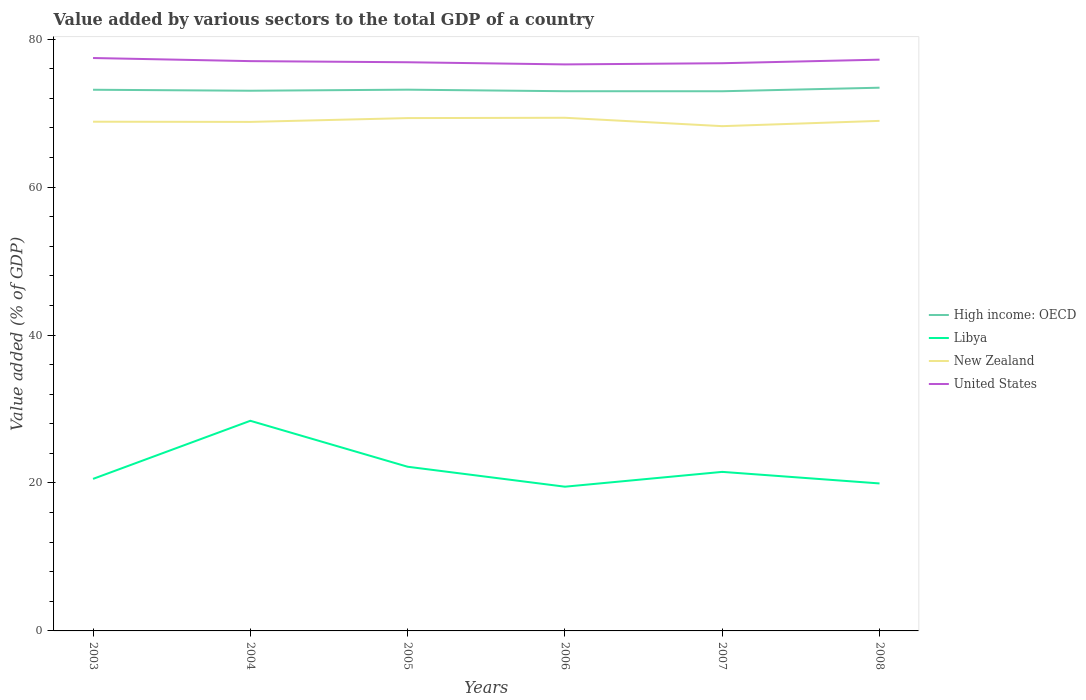How many different coloured lines are there?
Provide a short and direct response. 4. Does the line corresponding to Libya intersect with the line corresponding to United States?
Give a very brief answer. No. Is the number of lines equal to the number of legend labels?
Provide a succinct answer. Yes. Across all years, what is the maximum value added by various sectors to the total GDP in High income: OECD?
Make the answer very short. 72.95. In which year was the value added by various sectors to the total GDP in United States maximum?
Your answer should be very brief. 2006. What is the total value added by various sectors to the total GDP in High income: OECD in the graph?
Offer a very short reply. 0.21. What is the difference between the highest and the second highest value added by various sectors to the total GDP in High income: OECD?
Your answer should be very brief. 0.48. What is the difference between the highest and the lowest value added by various sectors to the total GDP in Libya?
Make the answer very short. 2. Is the value added by various sectors to the total GDP in Libya strictly greater than the value added by various sectors to the total GDP in United States over the years?
Give a very brief answer. Yes. Are the values on the major ticks of Y-axis written in scientific E-notation?
Provide a short and direct response. No. Does the graph contain grids?
Make the answer very short. No. Where does the legend appear in the graph?
Make the answer very short. Center right. How are the legend labels stacked?
Keep it short and to the point. Vertical. What is the title of the graph?
Give a very brief answer. Value added by various sectors to the total GDP of a country. What is the label or title of the Y-axis?
Ensure brevity in your answer.  Value added (% of GDP). What is the Value added (% of GDP) in High income: OECD in 2003?
Make the answer very short. 73.16. What is the Value added (% of GDP) in Libya in 2003?
Offer a terse response. 20.55. What is the Value added (% of GDP) of New Zealand in 2003?
Offer a terse response. 68.83. What is the Value added (% of GDP) in United States in 2003?
Ensure brevity in your answer.  77.45. What is the Value added (% of GDP) of High income: OECD in 2004?
Keep it short and to the point. 73.02. What is the Value added (% of GDP) in Libya in 2004?
Offer a terse response. 28.41. What is the Value added (% of GDP) in New Zealand in 2004?
Offer a terse response. 68.81. What is the Value added (% of GDP) of United States in 2004?
Ensure brevity in your answer.  77.02. What is the Value added (% of GDP) in High income: OECD in 2005?
Offer a very short reply. 73.16. What is the Value added (% of GDP) in Libya in 2005?
Offer a terse response. 22.19. What is the Value added (% of GDP) of New Zealand in 2005?
Offer a very short reply. 69.32. What is the Value added (% of GDP) in United States in 2005?
Make the answer very short. 76.87. What is the Value added (% of GDP) of High income: OECD in 2006?
Your response must be concise. 72.96. What is the Value added (% of GDP) in Libya in 2006?
Your answer should be very brief. 19.5. What is the Value added (% of GDP) of New Zealand in 2006?
Ensure brevity in your answer.  69.37. What is the Value added (% of GDP) in United States in 2006?
Offer a very short reply. 76.58. What is the Value added (% of GDP) in High income: OECD in 2007?
Make the answer very short. 72.95. What is the Value added (% of GDP) of Libya in 2007?
Your answer should be very brief. 21.5. What is the Value added (% of GDP) in New Zealand in 2007?
Your answer should be compact. 68.23. What is the Value added (% of GDP) of United States in 2007?
Give a very brief answer. 76.74. What is the Value added (% of GDP) in High income: OECD in 2008?
Your answer should be compact. 73.43. What is the Value added (% of GDP) in Libya in 2008?
Offer a very short reply. 19.94. What is the Value added (% of GDP) of New Zealand in 2008?
Keep it short and to the point. 68.95. What is the Value added (% of GDP) in United States in 2008?
Give a very brief answer. 77.22. Across all years, what is the maximum Value added (% of GDP) in High income: OECD?
Offer a terse response. 73.43. Across all years, what is the maximum Value added (% of GDP) in Libya?
Keep it short and to the point. 28.41. Across all years, what is the maximum Value added (% of GDP) of New Zealand?
Give a very brief answer. 69.37. Across all years, what is the maximum Value added (% of GDP) of United States?
Offer a terse response. 77.45. Across all years, what is the minimum Value added (% of GDP) in High income: OECD?
Provide a succinct answer. 72.95. Across all years, what is the minimum Value added (% of GDP) in Libya?
Your response must be concise. 19.5. Across all years, what is the minimum Value added (% of GDP) of New Zealand?
Ensure brevity in your answer.  68.23. Across all years, what is the minimum Value added (% of GDP) of United States?
Your answer should be very brief. 76.58. What is the total Value added (% of GDP) of High income: OECD in the graph?
Provide a short and direct response. 438.68. What is the total Value added (% of GDP) in Libya in the graph?
Offer a very short reply. 132.08. What is the total Value added (% of GDP) of New Zealand in the graph?
Provide a succinct answer. 413.51. What is the total Value added (% of GDP) in United States in the graph?
Your answer should be very brief. 461.89. What is the difference between the Value added (% of GDP) in High income: OECD in 2003 and that in 2004?
Offer a very short reply. 0.13. What is the difference between the Value added (% of GDP) of Libya in 2003 and that in 2004?
Offer a very short reply. -7.85. What is the difference between the Value added (% of GDP) of New Zealand in 2003 and that in 2004?
Your answer should be compact. 0.03. What is the difference between the Value added (% of GDP) in United States in 2003 and that in 2004?
Your response must be concise. 0.42. What is the difference between the Value added (% of GDP) of High income: OECD in 2003 and that in 2005?
Ensure brevity in your answer.  -0.01. What is the difference between the Value added (% of GDP) of Libya in 2003 and that in 2005?
Provide a short and direct response. -1.64. What is the difference between the Value added (% of GDP) in New Zealand in 2003 and that in 2005?
Give a very brief answer. -0.49. What is the difference between the Value added (% of GDP) in United States in 2003 and that in 2005?
Your response must be concise. 0.57. What is the difference between the Value added (% of GDP) in High income: OECD in 2003 and that in 2006?
Your answer should be compact. 0.2. What is the difference between the Value added (% of GDP) in Libya in 2003 and that in 2006?
Your answer should be compact. 1.06. What is the difference between the Value added (% of GDP) in New Zealand in 2003 and that in 2006?
Your answer should be very brief. -0.53. What is the difference between the Value added (% of GDP) in United States in 2003 and that in 2006?
Offer a very short reply. 0.86. What is the difference between the Value added (% of GDP) in High income: OECD in 2003 and that in 2007?
Offer a terse response. 0.2. What is the difference between the Value added (% of GDP) in Libya in 2003 and that in 2007?
Offer a terse response. -0.95. What is the difference between the Value added (% of GDP) in New Zealand in 2003 and that in 2007?
Provide a short and direct response. 0.6. What is the difference between the Value added (% of GDP) of United States in 2003 and that in 2007?
Ensure brevity in your answer.  0.7. What is the difference between the Value added (% of GDP) in High income: OECD in 2003 and that in 2008?
Give a very brief answer. -0.28. What is the difference between the Value added (% of GDP) of Libya in 2003 and that in 2008?
Provide a short and direct response. 0.61. What is the difference between the Value added (% of GDP) of New Zealand in 2003 and that in 2008?
Give a very brief answer. -0.11. What is the difference between the Value added (% of GDP) of United States in 2003 and that in 2008?
Keep it short and to the point. 0.22. What is the difference between the Value added (% of GDP) in High income: OECD in 2004 and that in 2005?
Your answer should be very brief. -0.14. What is the difference between the Value added (% of GDP) in Libya in 2004 and that in 2005?
Offer a terse response. 6.21. What is the difference between the Value added (% of GDP) of New Zealand in 2004 and that in 2005?
Provide a short and direct response. -0.51. What is the difference between the Value added (% of GDP) of United States in 2004 and that in 2005?
Keep it short and to the point. 0.15. What is the difference between the Value added (% of GDP) in High income: OECD in 2004 and that in 2006?
Provide a succinct answer. 0.07. What is the difference between the Value added (% of GDP) in Libya in 2004 and that in 2006?
Your answer should be compact. 8.91. What is the difference between the Value added (% of GDP) in New Zealand in 2004 and that in 2006?
Offer a terse response. -0.56. What is the difference between the Value added (% of GDP) in United States in 2004 and that in 2006?
Provide a short and direct response. 0.44. What is the difference between the Value added (% of GDP) in High income: OECD in 2004 and that in 2007?
Provide a short and direct response. 0.07. What is the difference between the Value added (% of GDP) of Libya in 2004 and that in 2007?
Ensure brevity in your answer.  6.91. What is the difference between the Value added (% of GDP) of New Zealand in 2004 and that in 2007?
Give a very brief answer. 0.57. What is the difference between the Value added (% of GDP) in United States in 2004 and that in 2007?
Your answer should be compact. 0.28. What is the difference between the Value added (% of GDP) in High income: OECD in 2004 and that in 2008?
Your answer should be very brief. -0.41. What is the difference between the Value added (% of GDP) of Libya in 2004 and that in 2008?
Keep it short and to the point. 8.47. What is the difference between the Value added (% of GDP) in New Zealand in 2004 and that in 2008?
Keep it short and to the point. -0.14. What is the difference between the Value added (% of GDP) in United States in 2004 and that in 2008?
Offer a terse response. -0.2. What is the difference between the Value added (% of GDP) of High income: OECD in 2005 and that in 2006?
Ensure brevity in your answer.  0.21. What is the difference between the Value added (% of GDP) of Libya in 2005 and that in 2006?
Give a very brief answer. 2.7. What is the difference between the Value added (% of GDP) of New Zealand in 2005 and that in 2006?
Your response must be concise. -0.04. What is the difference between the Value added (% of GDP) in United States in 2005 and that in 2006?
Your answer should be very brief. 0.29. What is the difference between the Value added (% of GDP) of High income: OECD in 2005 and that in 2007?
Give a very brief answer. 0.21. What is the difference between the Value added (% of GDP) in Libya in 2005 and that in 2007?
Your response must be concise. 0.69. What is the difference between the Value added (% of GDP) of New Zealand in 2005 and that in 2007?
Ensure brevity in your answer.  1.09. What is the difference between the Value added (% of GDP) in United States in 2005 and that in 2007?
Offer a very short reply. 0.13. What is the difference between the Value added (% of GDP) of High income: OECD in 2005 and that in 2008?
Keep it short and to the point. -0.27. What is the difference between the Value added (% of GDP) of Libya in 2005 and that in 2008?
Ensure brevity in your answer.  2.26. What is the difference between the Value added (% of GDP) in New Zealand in 2005 and that in 2008?
Your response must be concise. 0.38. What is the difference between the Value added (% of GDP) in United States in 2005 and that in 2008?
Keep it short and to the point. -0.35. What is the difference between the Value added (% of GDP) of High income: OECD in 2006 and that in 2007?
Offer a terse response. 0. What is the difference between the Value added (% of GDP) of Libya in 2006 and that in 2007?
Provide a succinct answer. -2. What is the difference between the Value added (% of GDP) in New Zealand in 2006 and that in 2007?
Offer a very short reply. 1.13. What is the difference between the Value added (% of GDP) of United States in 2006 and that in 2007?
Give a very brief answer. -0.16. What is the difference between the Value added (% of GDP) of High income: OECD in 2006 and that in 2008?
Provide a succinct answer. -0.48. What is the difference between the Value added (% of GDP) in Libya in 2006 and that in 2008?
Give a very brief answer. -0.44. What is the difference between the Value added (% of GDP) of New Zealand in 2006 and that in 2008?
Your response must be concise. 0.42. What is the difference between the Value added (% of GDP) in United States in 2006 and that in 2008?
Give a very brief answer. -0.64. What is the difference between the Value added (% of GDP) of High income: OECD in 2007 and that in 2008?
Give a very brief answer. -0.48. What is the difference between the Value added (% of GDP) of Libya in 2007 and that in 2008?
Offer a terse response. 1.56. What is the difference between the Value added (% of GDP) of New Zealand in 2007 and that in 2008?
Your answer should be very brief. -0.71. What is the difference between the Value added (% of GDP) in United States in 2007 and that in 2008?
Offer a very short reply. -0.48. What is the difference between the Value added (% of GDP) of High income: OECD in 2003 and the Value added (% of GDP) of Libya in 2004?
Keep it short and to the point. 44.75. What is the difference between the Value added (% of GDP) of High income: OECD in 2003 and the Value added (% of GDP) of New Zealand in 2004?
Give a very brief answer. 4.35. What is the difference between the Value added (% of GDP) in High income: OECD in 2003 and the Value added (% of GDP) in United States in 2004?
Your answer should be compact. -3.87. What is the difference between the Value added (% of GDP) in Libya in 2003 and the Value added (% of GDP) in New Zealand in 2004?
Provide a succinct answer. -48.26. What is the difference between the Value added (% of GDP) of Libya in 2003 and the Value added (% of GDP) of United States in 2004?
Your answer should be very brief. -56.47. What is the difference between the Value added (% of GDP) of New Zealand in 2003 and the Value added (% of GDP) of United States in 2004?
Give a very brief answer. -8.19. What is the difference between the Value added (% of GDP) of High income: OECD in 2003 and the Value added (% of GDP) of Libya in 2005?
Your response must be concise. 50.96. What is the difference between the Value added (% of GDP) of High income: OECD in 2003 and the Value added (% of GDP) of New Zealand in 2005?
Your response must be concise. 3.83. What is the difference between the Value added (% of GDP) in High income: OECD in 2003 and the Value added (% of GDP) in United States in 2005?
Provide a succinct answer. -3.72. What is the difference between the Value added (% of GDP) in Libya in 2003 and the Value added (% of GDP) in New Zealand in 2005?
Keep it short and to the point. -48.77. What is the difference between the Value added (% of GDP) in Libya in 2003 and the Value added (% of GDP) in United States in 2005?
Provide a succinct answer. -56.32. What is the difference between the Value added (% of GDP) of New Zealand in 2003 and the Value added (% of GDP) of United States in 2005?
Give a very brief answer. -8.04. What is the difference between the Value added (% of GDP) in High income: OECD in 2003 and the Value added (% of GDP) in Libya in 2006?
Provide a succinct answer. 53.66. What is the difference between the Value added (% of GDP) in High income: OECD in 2003 and the Value added (% of GDP) in New Zealand in 2006?
Offer a very short reply. 3.79. What is the difference between the Value added (% of GDP) in High income: OECD in 2003 and the Value added (% of GDP) in United States in 2006?
Your answer should be very brief. -3.43. What is the difference between the Value added (% of GDP) in Libya in 2003 and the Value added (% of GDP) in New Zealand in 2006?
Your response must be concise. -48.82. What is the difference between the Value added (% of GDP) of Libya in 2003 and the Value added (% of GDP) of United States in 2006?
Your answer should be very brief. -56.03. What is the difference between the Value added (% of GDP) of New Zealand in 2003 and the Value added (% of GDP) of United States in 2006?
Make the answer very short. -7.75. What is the difference between the Value added (% of GDP) of High income: OECD in 2003 and the Value added (% of GDP) of Libya in 2007?
Give a very brief answer. 51.66. What is the difference between the Value added (% of GDP) of High income: OECD in 2003 and the Value added (% of GDP) of New Zealand in 2007?
Your answer should be compact. 4.92. What is the difference between the Value added (% of GDP) in High income: OECD in 2003 and the Value added (% of GDP) in United States in 2007?
Give a very brief answer. -3.59. What is the difference between the Value added (% of GDP) of Libya in 2003 and the Value added (% of GDP) of New Zealand in 2007?
Keep it short and to the point. -47.68. What is the difference between the Value added (% of GDP) of Libya in 2003 and the Value added (% of GDP) of United States in 2007?
Make the answer very short. -56.19. What is the difference between the Value added (% of GDP) in New Zealand in 2003 and the Value added (% of GDP) in United States in 2007?
Provide a succinct answer. -7.91. What is the difference between the Value added (% of GDP) in High income: OECD in 2003 and the Value added (% of GDP) in Libya in 2008?
Keep it short and to the point. 53.22. What is the difference between the Value added (% of GDP) in High income: OECD in 2003 and the Value added (% of GDP) in New Zealand in 2008?
Make the answer very short. 4.21. What is the difference between the Value added (% of GDP) in High income: OECD in 2003 and the Value added (% of GDP) in United States in 2008?
Offer a terse response. -4.07. What is the difference between the Value added (% of GDP) in Libya in 2003 and the Value added (% of GDP) in New Zealand in 2008?
Offer a terse response. -48.39. What is the difference between the Value added (% of GDP) in Libya in 2003 and the Value added (% of GDP) in United States in 2008?
Make the answer very short. -56.67. What is the difference between the Value added (% of GDP) in New Zealand in 2003 and the Value added (% of GDP) in United States in 2008?
Ensure brevity in your answer.  -8.39. What is the difference between the Value added (% of GDP) of High income: OECD in 2004 and the Value added (% of GDP) of Libya in 2005?
Provide a short and direct response. 50.83. What is the difference between the Value added (% of GDP) of High income: OECD in 2004 and the Value added (% of GDP) of New Zealand in 2005?
Give a very brief answer. 3.7. What is the difference between the Value added (% of GDP) in High income: OECD in 2004 and the Value added (% of GDP) in United States in 2005?
Keep it short and to the point. -3.85. What is the difference between the Value added (% of GDP) in Libya in 2004 and the Value added (% of GDP) in New Zealand in 2005?
Give a very brief answer. -40.92. What is the difference between the Value added (% of GDP) of Libya in 2004 and the Value added (% of GDP) of United States in 2005?
Offer a terse response. -48.47. What is the difference between the Value added (% of GDP) of New Zealand in 2004 and the Value added (% of GDP) of United States in 2005?
Your response must be concise. -8.06. What is the difference between the Value added (% of GDP) in High income: OECD in 2004 and the Value added (% of GDP) in Libya in 2006?
Give a very brief answer. 53.53. What is the difference between the Value added (% of GDP) of High income: OECD in 2004 and the Value added (% of GDP) of New Zealand in 2006?
Keep it short and to the point. 3.66. What is the difference between the Value added (% of GDP) in High income: OECD in 2004 and the Value added (% of GDP) in United States in 2006?
Provide a succinct answer. -3.56. What is the difference between the Value added (% of GDP) of Libya in 2004 and the Value added (% of GDP) of New Zealand in 2006?
Provide a short and direct response. -40.96. What is the difference between the Value added (% of GDP) in Libya in 2004 and the Value added (% of GDP) in United States in 2006?
Make the answer very short. -48.18. What is the difference between the Value added (% of GDP) of New Zealand in 2004 and the Value added (% of GDP) of United States in 2006?
Give a very brief answer. -7.77. What is the difference between the Value added (% of GDP) in High income: OECD in 2004 and the Value added (% of GDP) in Libya in 2007?
Provide a succinct answer. 51.52. What is the difference between the Value added (% of GDP) in High income: OECD in 2004 and the Value added (% of GDP) in New Zealand in 2007?
Provide a short and direct response. 4.79. What is the difference between the Value added (% of GDP) in High income: OECD in 2004 and the Value added (% of GDP) in United States in 2007?
Provide a short and direct response. -3.72. What is the difference between the Value added (% of GDP) of Libya in 2004 and the Value added (% of GDP) of New Zealand in 2007?
Keep it short and to the point. -39.83. What is the difference between the Value added (% of GDP) of Libya in 2004 and the Value added (% of GDP) of United States in 2007?
Give a very brief answer. -48.33. What is the difference between the Value added (% of GDP) of New Zealand in 2004 and the Value added (% of GDP) of United States in 2007?
Your response must be concise. -7.93. What is the difference between the Value added (% of GDP) in High income: OECD in 2004 and the Value added (% of GDP) in Libya in 2008?
Provide a short and direct response. 53.09. What is the difference between the Value added (% of GDP) of High income: OECD in 2004 and the Value added (% of GDP) of New Zealand in 2008?
Your answer should be compact. 4.08. What is the difference between the Value added (% of GDP) in High income: OECD in 2004 and the Value added (% of GDP) in United States in 2008?
Your answer should be very brief. -4.2. What is the difference between the Value added (% of GDP) of Libya in 2004 and the Value added (% of GDP) of New Zealand in 2008?
Your response must be concise. -40.54. What is the difference between the Value added (% of GDP) of Libya in 2004 and the Value added (% of GDP) of United States in 2008?
Your answer should be very brief. -48.82. What is the difference between the Value added (% of GDP) of New Zealand in 2004 and the Value added (% of GDP) of United States in 2008?
Your answer should be compact. -8.41. What is the difference between the Value added (% of GDP) in High income: OECD in 2005 and the Value added (% of GDP) in Libya in 2006?
Provide a succinct answer. 53.67. What is the difference between the Value added (% of GDP) of High income: OECD in 2005 and the Value added (% of GDP) of New Zealand in 2006?
Your response must be concise. 3.8. What is the difference between the Value added (% of GDP) of High income: OECD in 2005 and the Value added (% of GDP) of United States in 2006?
Your answer should be compact. -3.42. What is the difference between the Value added (% of GDP) of Libya in 2005 and the Value added (% of GDP) of New Zealand in 2006?
Offer a terse response. -47.17. What is the difference between the Value added (% of GDP) in Libya in 2005 and the Value added (% of GDP) in United States in 2006?
Your response must be concise. -54.39. What is the difference between the Value added (% of GDP) of New Zealand in 2005 and the Value added (% of GDP) of United States in 2006?
Make the answer very short. -7.26. What is the difference between the Value added (% of GDP) in High income: OECD in 2005 and the Value added (% of GDP) in Libya in 2007?
Your answer should be compact. 51.67. What is the difference between the Value added (% of GDP) in High income: OECD in 2005 and the Value added (% of GDP) in New Zealand in 2007?
Provide a short and direct response. 4.93. What is the difference between the Value added (% of GDP) in High income: OECD in 2005 and the Value added (% of GDP) in United States in 2007?
Your answer should be compact. -3.58. What is the difference between the Value added (% of GDP) of Libya in 2005 and the Value added (% of GDP) of New Zealand in 2007?
Provide a short and direct response. -46.04. What is the difference between the Value added (% of GDP) in Libya in 2005 and the Value added (% of GDP) in United States in 2007?
Offer a very short reply. -54.55. What is the difference between the Value added (% of GDP) in New Zealand in 2005 and the Value added (% of GDP) in United States in 2007?
Offer a very short reply. -7.42. What is the difference between the Value added (% of GDP) in High income: OECD in 2005 and the Value added (% of GDP) in Libya in 2008?
Your response must be concise. 53.23. What is the difference between the Value added (% of GDP) of High income: OECD in 2005 and the Value added (% of GDP) of New Zealand in 2008?
Your answer should be very brief. 4.22. What is the difference between the Value added (% of GDP) in High income: OECD in 2005 and the Value added (% of GDP) in United States in 2008?
Your answer should be very brief. -4.06. What is the difference between the Value added (% of GDP) in Libya in 2005 and the Value added (% of GDP) in New Zealand in 2008?
Provide a short and direct response. -46.75. What is the difference between the Value added (% of GDP) of Libya in 2005 and the Value added (% of GDP) of United States in 2008?
Make the answer very short. -55.03. What is the difference between the Value added (% of GDP) of New Zealand in 2005 and the Value added (% of GDP) of United States in 2008?
Your answer should be compact. -7.9. What is the difference between the Value added (% of GDP) of High income: OECD in 2006 and the Value added (% of GDP) of Libya in 2007?
Provide a short and direct response. 51.46. What is the difference between the Value added (% of GDP) in High income: OECD in 2006 and the Value added (% of GDP) in New Zealand in 2007?
Keep it short and to the point. 4.72. What is the difference between the Value added (% of GDP) in High income: OECD in 2006 and the Value added (% of GDP) in United States in 2007?
Give a very brief answer. -3.79. What is the difference between the Value added (% of GDP) in Libya in 2006 and the Value added (% of GDP) in New Zealand in 2007?
Your answer should be very brief. -48.74. What is the difference between the Value added (% of GDP) of Libya in 2006 and the Value added (% of GDP) of United States in 2007?
Provide a short and direct response. -57.24. What is the difference between the Value added (% of GDP) in New Zealand in 2006 and the Value added (% of GDP) in United States in 2007?
Offer a terse response. -7.37. What is the difference between the Value added (% of GDP) in High income: OECD in 2006 and the Value added (% of GDP) in Libya in 2008?
Your answer should be compact. 53.02. What is the difference between the Value added (% of GDP) of High income: OECD in 2006 and the Value added (% of GDP) of New Zealand in 2008?
Your answer should be very brief. 4.01. What is the difference between the Value added (% of GDP) of High income: OECD in 2006 and the Value added (% of GDP) of United States in 2008?
Offer a very short reply. -4.27. What is the difference between the Value added (% of GDP) of Libya in 2006 and the Value added (% of GDP) of New Zealand in 2008?
Provide a short and direct response. -49.45. What is the difference between the Value added (% of GDP) in Libya in 2006 and the Value added (% of GDP) in United States in 2008?
Your answer should be compact. -57.73. What is the difference between the Value added (% of GDP) in New Zealand in 2006 and the Value added (% of GDP) in United States in 2008?
Your response must be concise. -7.86. What is the difference between the Value added (% of GDP) in High income: OECD in 2007 and the Value added (% of GDP) in Libya in 2008?
Your answer should be compact. 53.02. What is the difference between the Value added (% of GDP) in High income: OECD in 2007 and the Value added (% of GDP) in New Zealand in 2008?
Offer a very short reply. 4.01. What is the difference between the Value added (% of GDP) in High income: OECD in 2007 and the Value added (% of GDP) in United States in 2008?
Keep it short and to the point. -4.27. What is the difference between the Value added (% of GDP) of Libya in 2007 and the Value added (% of GDP) of New Zealand in 2008?
Your answer should be compact. -47.45. What is the difference between the Value added (% of GDP) of Libya in 2007 and the Value added (% of GDP) of United States in 2008?
Ensure brevity in your answer.  -55.72. What is the difference between the Value added (% of GDP) of New Zealand in 2007 and the Value added (% of GDP) of United States in 2008?
Offer a terse response. -8.99. What is the average Value added (% of GDP) in High income: OECD per year?
Your answer should be very brief. 73.11. What is the average Value added (% of GDP) in Libya per year?
Offer a very short reply. 22.01. What is the average Value added (% of GDP) in New Zealand per year?
Give a very brief answer. 68.92. What is the average Value added (% of GDP) in United States per year?
Your answer should be very brief. 76.98. In the year 2003, what is the difference between the Value added (% of GDP) in High income: OECD and Value added (% of GDP) in Libya?
Your response must be concise. 52.6. In the year 2003, what is the difference between the Value added (% of GDP) in High income: OECD and Value added (% of GDP) in New Zealand?
Provide a short and direct response. 4.32. In the year 2003, what is the difference between the Value added (% of GDP) of High income: OECD and Value added (% of GDP) of United States?
Provide a short and direct response. -4.29. In the year 2003, what is the difference between the Value added (% of GDP) in Libya and Value added (% of GDP) in New Zealand?
Your answer should be compact. -48.28. In the year 2003, what is the difference between the Value added (% of GDP) of Libya and Value added (% of GDP) of United States?
Provide a succinct answer. -56.89. In the year 2003, what is the difference between the Value added (% of GDP) of New Zealand and Value added (% of GDP) of United States?
Your answer should be compact. -8.61. In the year 2004, what is the difference between the Value added (% of GDP) of High income: OECD and Value added (% of GDP) of Libya?
Offer a very short reply. 44.62. In the year 2004, what is the difference between the Value added (% of GDP) in High income: OECD and Value added (% of GDP) in New Zealand?
Provide a short and direct response. 4.21. In the year 2004, what is the difference between the Value added (% of GDP) in High income: OECD and Value added (% of GDP) in United States?
Keep it short and to the point. -4. In the year 2004, what is the difference between the Value added (% of GDP) of Libya and Value added (% of GDP) of New Zealand?
Offer a terse response. -40.4. In the year 2004, what is the difference between the Value added (% of GDP) in Libya and Value added (% of GDP) in United States?
Ensure brevity in your answer.  -48.62. In the year 2004, what is the difference between the Value added (% of GDP) in New Zealand and Value added (% of GDP) in United States?
Give a very brief answer. -8.22. In the year 2005, what is the difference between the Value added (% of GDP) in High income: OECD and Value added (% of GDP) in Libya?
Provide a succinct answer. 50.97. In the year 2005, what is the difference between the Value added (% of GDP) of High income: OECD and Value added (% of GDP) of New Zealand?
Provide a succinct answer. 3.84. In the year 2005, what is the difference between the Value added (% of GDP) in High income: OECD and Value added (% of GDP) in United States?
Provide a succinct answer. -3.71. In the year 2005, what is the difference between the Value added (% of GDP) in Libya and Value added (% of GDP) in New Zealand?
Your answer should be compact. -47.13. In the year 2005, what is the difference between the Value added (% of GDP) of Libya and Value added (% of GDP) of United States?
Offer a very short reply. -54.68. In the year 2005, what is the difference between the Value added (% of GDP) of New Zealand and Value added (% of GDP) of United States?
Keep it short and to the point. -7.55. In the year 2006, what is the difference between the Value added (% of GDP) of High income: OECD and Value added (% of GDP) of Libya?
Offer a very short reply. 53.46. In the year 2006, what is the difference between the Value added (% of GDP) in High income: OECD and Value added (% of GDP) in New Zealand?
Make the answer very short. 3.59. In the year 2006, what is the difference between the Value added (% of GDP) in High income: OECD and Value added (% of GDP) in United States?
Your answer should be very brief. -3.63. In the year 2006, what is the difference between the Value added (% of GDP) in Libya and Value added (% of GDP) in New Zealand?
Offer a terse response. -49.87. In the year 2006, what is the difference between the Value added (% of GDP) in Libya and Value added (% of GDP) in United States?
Offer a terse response. -57.09. In the year 2006, what is the difference between the Value added (% of GDP) of New Zealand and Value added (% of GDP) of United States?
Keep it short and to the point. -7.21. In the year 2007, what is the difference between the Value added (% of GDP) of High income: OECD and Value added (% of GDP) of Libya?
Give a very brief answer. 51.45. In the year 2007, what is the difference between the Value added (% of GDP) in High income: OECD and Value added (% of GDP) in New Zealand?
Give a very brief answer. 4.72. In the year 2007, what is the difference between the Value added (% of GDP) of High income: OECD and Value added (% of GDP) of United States?
Offer a terse response. -3.79. In the year 2007, what is the difference between the Value added (% of GDP) of Libya and Value added (% of GDP) of New Zealand?
Ensure brevity in your answer.  -46.73. In the year 2007, what is the difference between the Value added (% of GDP) in Libya and Value added (% of GDP) in United States?
Your answer should be compact. -55.24. In the year 2007, what is the difference between the Value added (% of GDP) in New Zealand and Value added (% of GDP) in United States?
Provide a short and direct response. -8.51. In the year 2008, what is the difference between the Value added (% of GDP) in High income: OECD and Value added (% of GDP) in Libya?
Ensure brevity in your answer.  53.49. In the year 2008, what is the difference between the Value added (% of GDP) in High income: OECD and Value added (% of GDP) in New Zealand?
Make the answer very short. 4.48. In the year 2008, what is the difference between the Value added (% of GDP) of High income: OECD and Value added (% of GDP) of United States?
Make the answer very short. -3.79. In the year 2008, what is the difference between the Value added (% of GDP) of Libya and Value added (% of GDP) of New Zealand?
Ensure brevity in your answer.  -49.01. In the year 2008, what is the difference between the Value added (% of GDP) in Libya and Value added (% of GDP) in United States?
Your response must be concise. -57.29. In the year 2008, what is the difference between the Value added (% of GDP) of New Zealand and Value added (% of GDP) of United States?
Provide a succinct answer. -8.28. What is the ratio of the Value added (% of GDP) of High income: OECD in 2003 to that in 2004?
Offer a terse response. 1. What is the ratio of the Value added (% of GDP) in Libya in 2003 to that in 2004?
Keep it short and to the point. 0.72. What is the ratio of the Value added (% of GDP) of Libya in 2003 to that in 2005?
Your response must be concise. 0.93. What is the ratio of the Value added (% of GDP) of United States in 2003 to that in 2005?
Make the answer very short. 1.01. What is the ratio of the Value added (% of GDP) of High income: OECD in 2003 to that in 2006?
Make the answer very short. 1. What is the ratio of the Value added (% of GDP) of Libya in 2003 to that in 2006?
Offer a very short reply. 1.05. What is the ratio of the Value added (% of GDP) of New Zealand in 2003 to that in 2006?
Your answer should be very brief. 0.99. What is the ratio of the Value added (% of GDP) of United States in 2003 to that in 2006?
Offer a terse response. 1.01. What is the ratio of the Value added (% of GDP) in Libya in 2003 to that in 2007?
Your response must be concise. 0.96. What is the ratio of the Value added (% of GDP) of New Zealand in 2003 to that in 2007?
Your answer should be compact. 1.01. What is the ratio of the Value added (% of GDP) in United States in 2003 to that in 2007?
Your response must be concise. 1.01. What is the ratio of the Value added (% of GDP) of Libya in 2003 to that in 2008?
Your answer should be compact. 1.03. What is the ratio of the Value added (% of GDP) in New Zealand in 2003 to that in 2008?
Your answer should be compact. 1. What is the ratio of the Value added (% of GDP) in United States in 2003 to that in 2008?
Your answer should be very brief. 1. What is the ratio of the Value added (% of GDP) in High income: OECD in 2004 to that in 2005?
Give a very brief answer. 1. What is the ratio of the Value added (% of GDP) of Libya in 2004 to that in 2005?
Ensure brevity in your answer.  1.28. What is the ratio of the Value added (% of GDP) of New Zealand in 2004 to that in 2005?
Give a very brief answer. 0.99. What is the ratio of the Value added (% of GDP) in Libya in 2004 to that in 2006?
Offer a terse response. 1.46. What is the ratio of the Value added (% of GDP) in New Zealand in 2004 to that in 2006?
Offer a terse response. 0.99. What is the ratio of the Value added (% of GDP) of High income: OECD in 2004 to that in 2007?
Offer a very short reply. 1. What is the ratio of the Value added (% of GDP) of Libya in 2004 to that in 2007?
Offer a very short reply. 1.32. What is the ratio of the Value added (% of GDP) of New Zealand in 2004 to that in 2007?
Provide a succinct answer. 1.01. What is the ratio of the Value added (% of GDP) in High income: OECD in 2004 to that in 2008?
Your answer should be compact. 0.99. What is the ratio of the Value added (% of GDP) of Libya in 2004 to that in 2008?
Make the answer very short. 1.42. What is the ratio of the Value added (% of GDP) of Libya in 2005 to that in 2006?
Your answer should be compact. 1.14. What is the ratio of the Value added (% of GDP) in United States in 2005 to that in 2006?
Keep it short and to the point. 1. What is the ratio of the Value added (% of GDP) in Libya in 2005 to that in 2007?
Your response must be concise. 1.03. What is the ratio of the Value added (% of GDP) in New Zealand in 2005 to that in 2007?
Offer a terse response. 1.02. What is the ratio of the Value added (% of GDP) of United States in 2005 to that in 2007?
Your response must be concise. 1. What is the ratio of the Value added (% of GDP) in Libya in 2005 to that in 2008?
Offer a terse response. 1.11. What is the ratio of the Value added (% of GDP) of United States in 2005 to that in 2008?
Give a very brief answer. 1. What is the ratio of the Value added (% of GDP) in High income: OECD in 2006 to that in 2007?
Provide a succinct answer. 1. What is the ratio of the Value added (% of GDP) in Libya in 2006 to that in 2007?
Ensure brevity in your answer.  0.91. What is the ratio of the Value added (% of GDP) of New Zealand in 2006 to that in 2007?
Your answer should be compact. 1.02. What is the ratio of the Value added (% of GDP) in United States in 2006 to that in 2007?
Offer a very short reply. 1. What is the ratio of the Value added (% of GDP) of High income: OECD in 2006 to that in 2008?
Provide a succinct answer. 0.99. What is the ratio of the Value added (% of GDP) of Libya in 2006 to that in 2008?
Offer a very short reply. 0.98. What is the ratio of the Value added (% of GDP) of New Zealand in 2006 to that in 2008?
Your answer should be very brief. 1.01. What is the ratio of the Value added (% of GDP) of United States in 2006 to that in 2008?
Keep it short and to the point. 0.99. What is the ratio of the Value added (% of GDP) in High income: OECD in 2007 to that in 2008?
Provide a short and direct response. 0.99. What is the ratio of the Value added (% of GDP) of Libya in 2007 to that in 2008?
Offer a terse response. 1.08. What is the ratio of the Value added (% of GDP) of New Zealand in 2007 to that in 2008?
Offer a very short reply. 0.99. What is the difference between the highest and the second highest Value added (% of GDP) of High income: OECD?
Provide a succinct answer. 0.27. What is the difference between the highest and the second highest Value added (% of GDP) of Libya?
Offer a very short reply. 6.21. What is the difference between the highest and the second highest Value added (% of GDP) in New Zealand?
Ensure brevity in your answer.  0.04. What is the difference between the highest and the second highest Value added (% of GDP) in United States?
Your answer should be very brief. 0.22. What is the difference between the highest and the lowest Value added (% of GDP) in High income: OECD?
Provide a succinct answer. 0.48. What is the difference between the highest and the lowest Value added (% of GDP) of Libya?
Your answer should be very brief. 8.91. What is the difference between the highest and the lowest Value added (% of GDP) of New Zealand?
Keep it short and to the point. 1.13. What is the difference between the highest and the lowest Value added (% of GDP) of United States?
Offer a terse response. 0.86. 